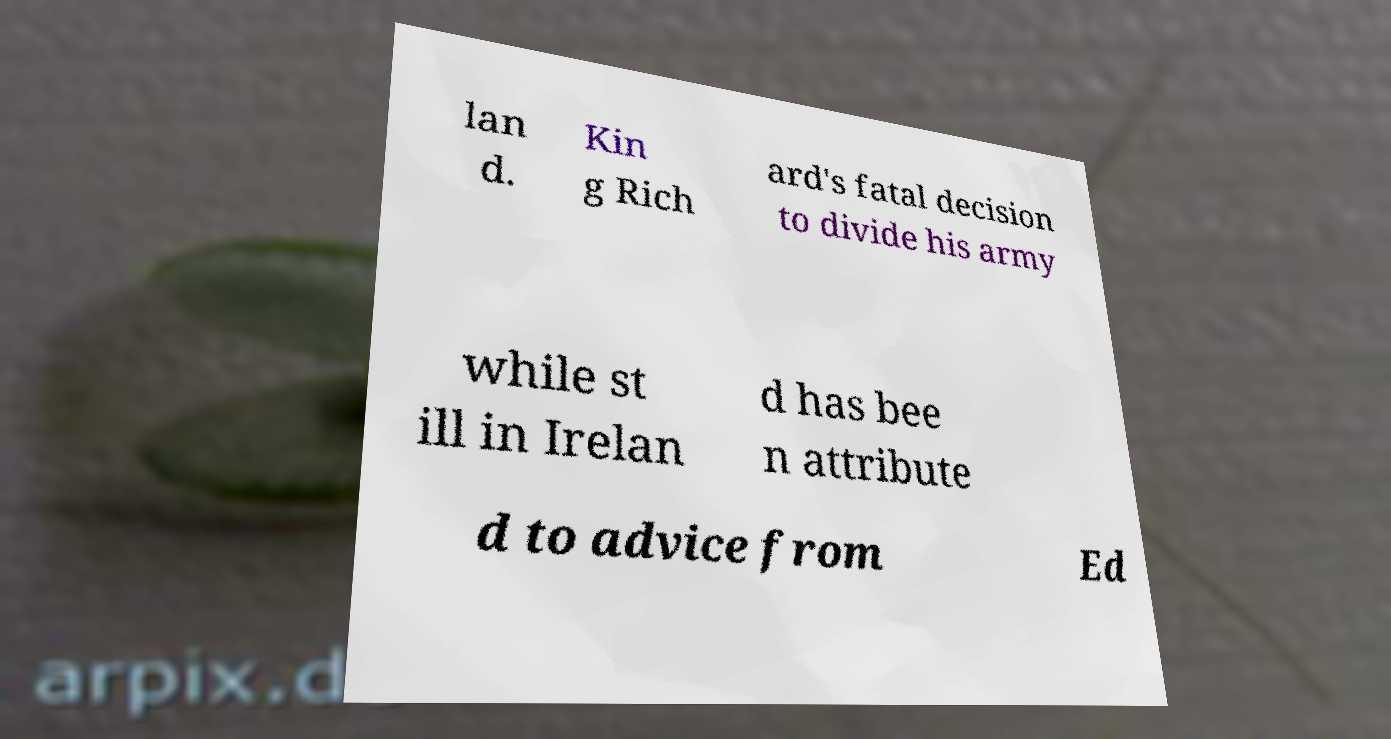Could you assist in decoding the text presented in this image and type it out clearly? lan d. Kin g Rich ard's fatal decision to divide his army while st ill in Irelan d has bee n attribute d to advice from Ed 